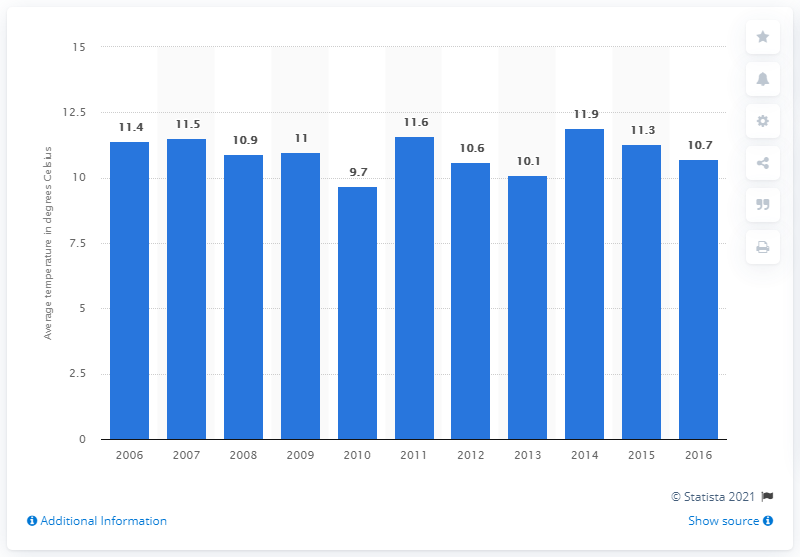Specify some key components in this picture. The highest temperature recorded in Belgium was in 2014. 